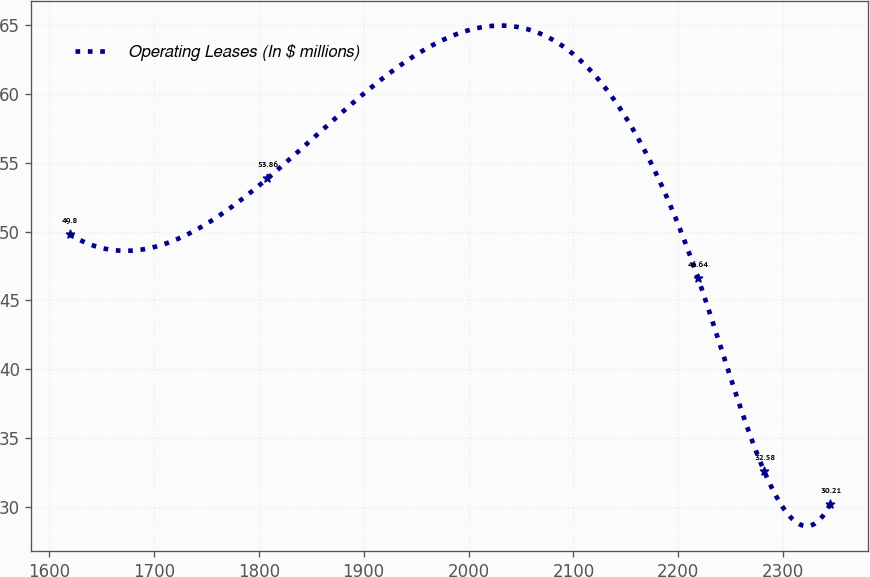<chart> <loc_0><loc_0><loc_500><loc_500><line_chart><ecel><fcel>Operating Leases (In $ millions)<nl><fcel>1619.67<fcel>49.8<nl><fcel>1808.36<fcel>53.86<nl><fcel>2218.64<fcel>46.64<nl><fcel>2281.78<fcel>32.58<nl><fcel>2344.92<fcel>30.21<nl></chart> 